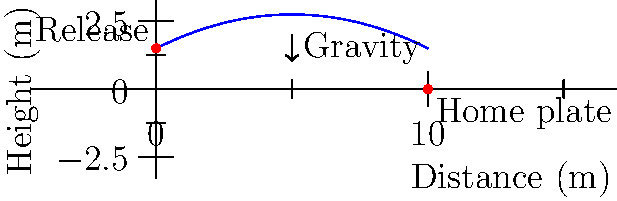In a baseball pitch, the ball follows a parabolic trajectory as shown in the diagram. If the ball is released at a height of 1.5 meters and travels 10 meters horizontally to reach home plate at ground level, what is the maximum height reached by the ball during its flight? To find the maximum height of the ball's trajectory, we need to follow these steps:

1. The trajectory of the ball follows a parabolic path, which can be described by the equation:

   $$y = -ax^2 + bx + c$$

   where $a$, $b$, and $c$ are constants, $x$ is the horizontal distance, and $y$ is the height.

2. We know three points on this parabola:
   - Initial point: (0, 1.5)
   - Final point: (10, 0)
   - Vertex (highest point): (unknown, unknown)

3. Using the initial and final points, we can set up two equations:
   1.5 = c (when x = 0)
   0 = -100a + 10b + 1.5 (when x = 10)

4. The axis of symmetry for a parabola occurs at $x = -b/(2a)$. This is where the maximum height occurs.

5. Given the symmetry of the parabola and the horizontal distance traveled, we can deduce that the maximum height occurs at x = 5 meters (halfway between 0 and 10).

6. Substituting x = 5 into our general equation:
   $$y_{max} = -25a + 5b + 1.5$$

7. To find $a$ and $b$, we use the equation from step 3:
   $$0 = -100a + 10b + 1.5$$
   $$-1.5 = -100a + 10b$$
   $$0.15 = 10a - b$$

8. Substituting this into the equation for $y_{max}$:
   $$y_{max} = -25a + 5(10a - 0.15) + 1.5$$
   $$y_{max} = -25a + 50a - 0.75 + 1.5$$
   $$y_{max} = 25a + 0.75$$

9. The exact value of $a$ isn't necessary to determine. We can see that the maximum height will be 0.75 meters above the release height.

10. Therefore, the maximum height is:
    $$1.5 + 0.75 = 2.25 \text{ meters}$$
Answer: 2.25 meters 